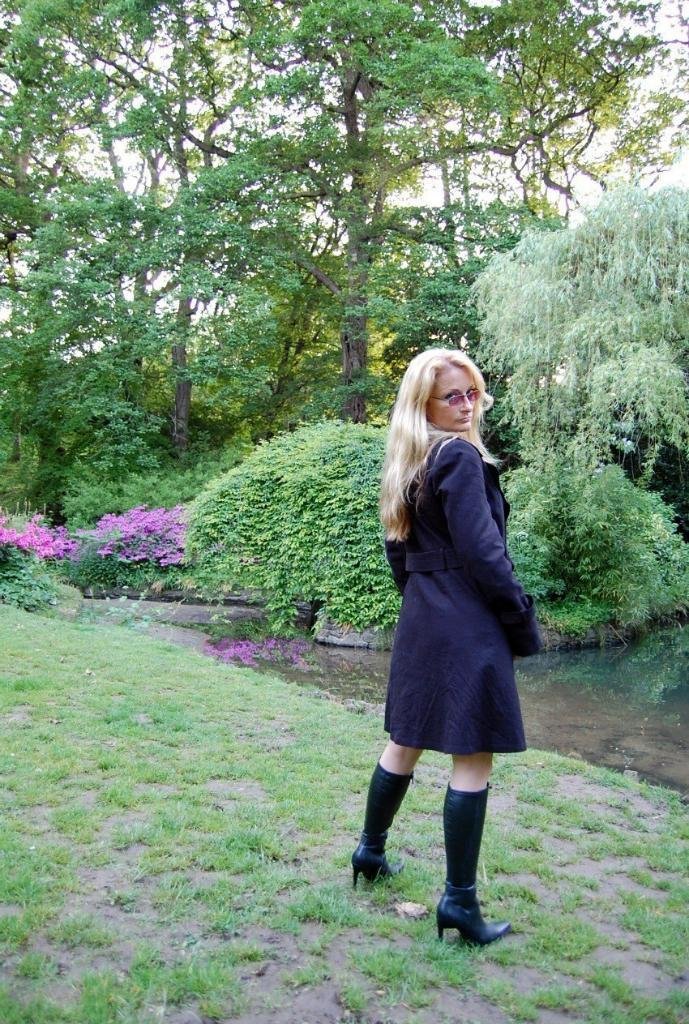What is the main subject of the image? There is a woman standing in the image. What type of vegetation can be seen in the image? There are plants, flowers, and grass visible in the image. What is in the background of the image? There are trees and the sky visible in the background of the image. What type of voyage is the woman embarking on in the image? There is no indication of a voyage in the image; it simply shows a woman standing amidst a natural environment. 